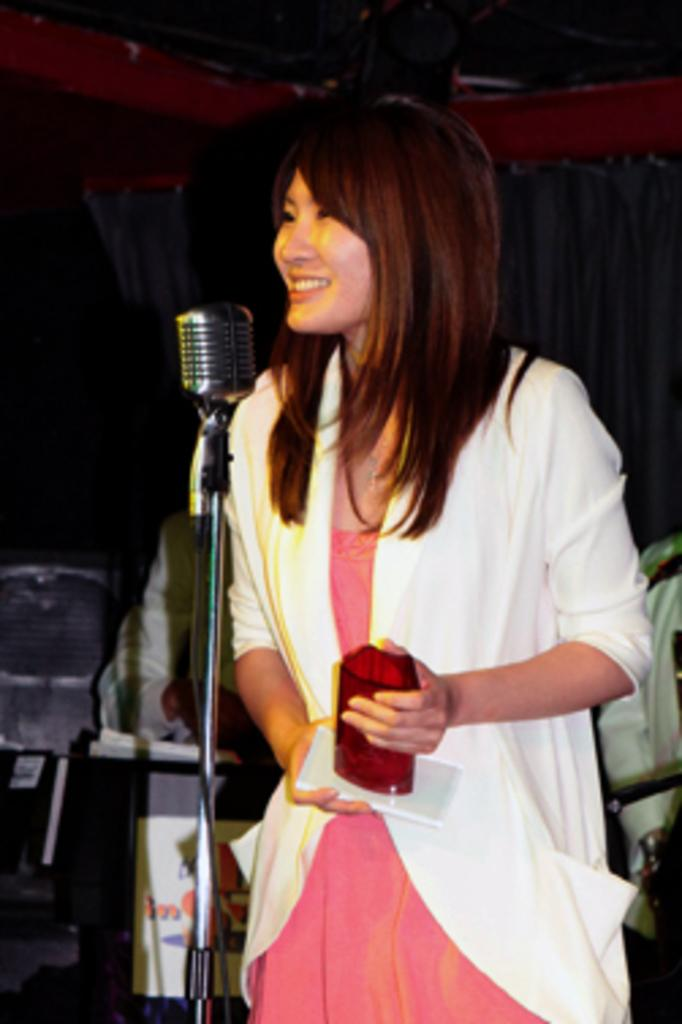What is the woman in the image doing? The woman is standing at the mic in the image. What can be seen in the background of the image? There are persons, a curtain, and a wall in the background of the image. What type of steel toe boots is the woman wearing in the image? The image does not show the woman's footwear, so it cannot be determined if she is wearing steel toe boots or any other type of footwear. 